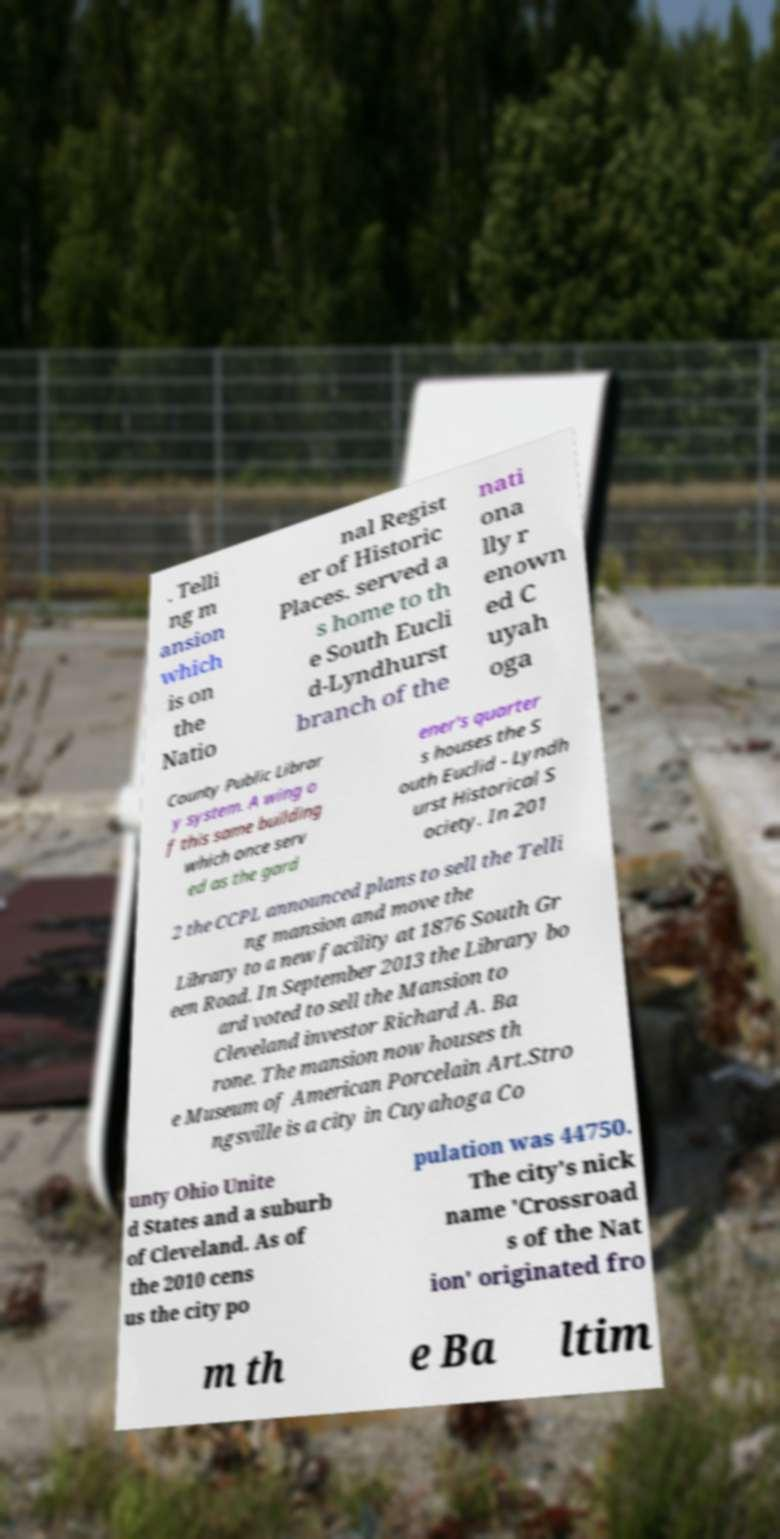For documentation purposes, I need the text within this image transcribed. Could you provide that? . Telli ng m ansion which is on the Natio nal Regist er of Historic Places. served a s home to th e South Eucli d-Lyndhurst branch of the nati ona lly r enown ed C uyah oga County Public Librar y system. A wing o f this same building which once serv ed as the gard ener's quarter s houses the S outh Euclid - Lyndh urst Historical S ociety. In 201 2 the CCPL announced plans to sell the Telli ng mansion and move the Library to a new facility at 1876 South Gr een Road. In September 2013 the Library bo ard voted to sell the Mansion to Cleveland investor Richard A. Ba rone. The mansion now houses th e Museum of American Porcelain Art.Stro ngsville is a city in Cuyahoga Co unty Ohio Unite d States and a suburb of Cleveland. As of the 2010 cens us the city po pulation was 44750. The city's nick name 'Crossroad s of the Nat ion' originated fro m th e Ba ltim 